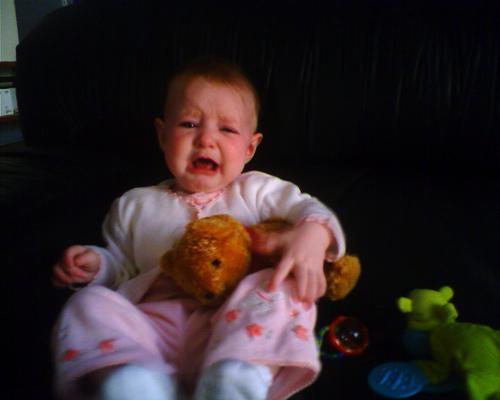How many babies are in the picture?
Give a very brief answer. 1. How many children are in the picture?
Give a very brief answer. 1. How many teddy bears are in the picture?
Give a very brief answer. 2. 